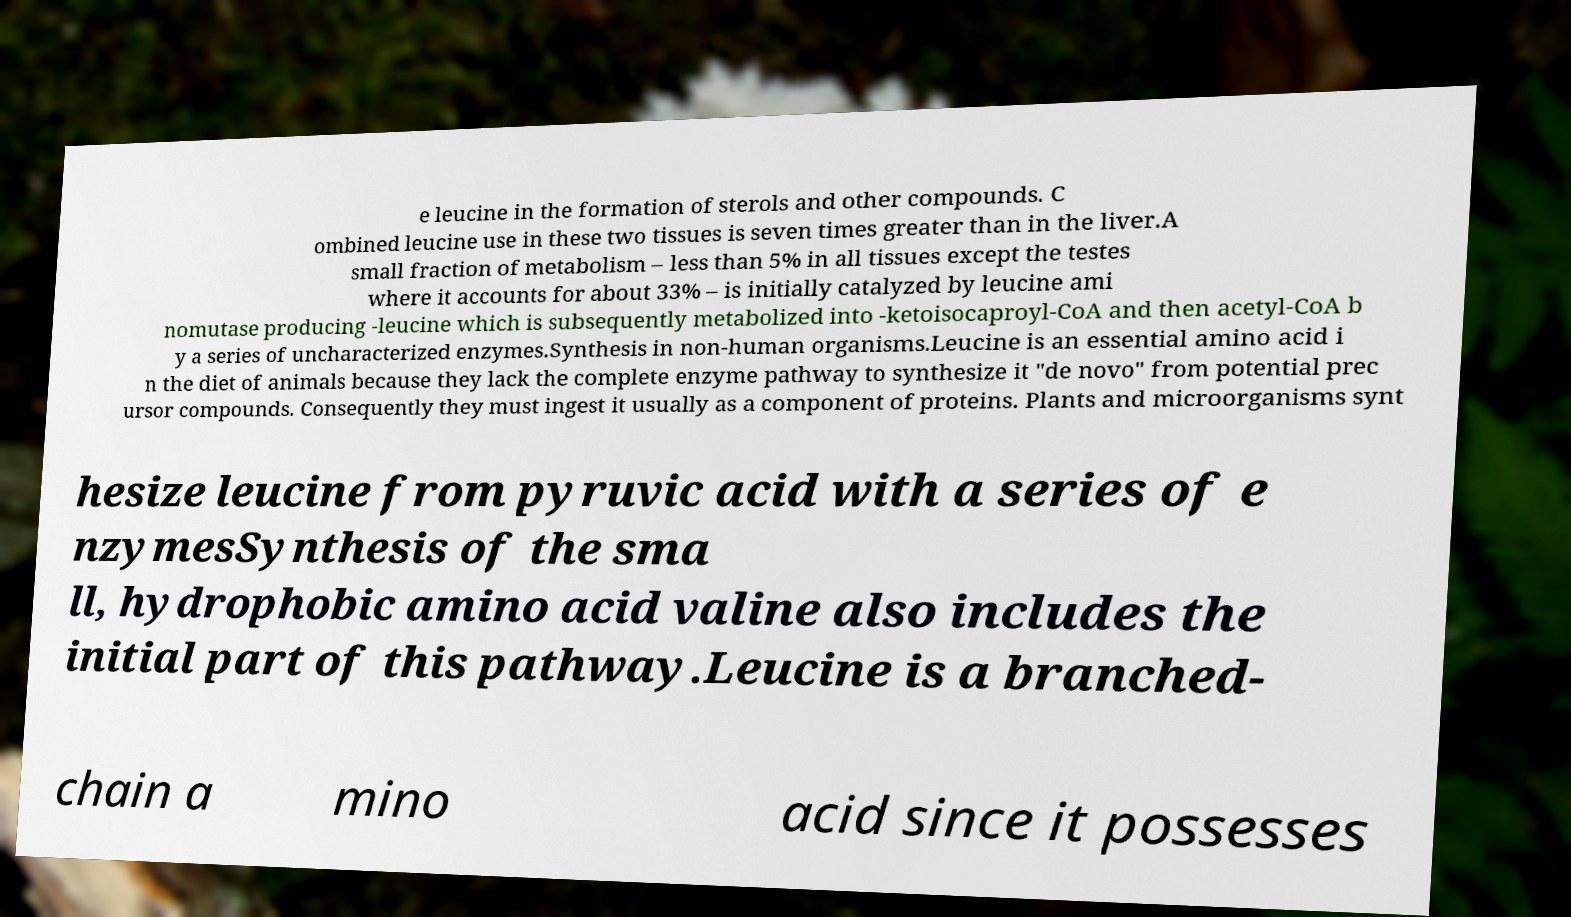Please identify and transcribe the text found in this image. e leucine in the formation of sterols and other compounds. C ombined leucine use in these two tissues is seven times greater than in the liver.A small fraction of metabolism – less than 5% in all tissues except the testes where it accounts for about 33% – is initially catalyzed by leucine ami nomutase producing -leucine which is subsequently metabolized into -ketoisocaproyl-CoA and then acetyl-CoA b y a series of uncharacterized enzymes.Synthesis in non-human organisms.Leucine is an essential amino acid i n the diet of animals because they lack the complete enzyme pathway to synthesize it "de novo" from potential prec ursor compounds. Consequently they must ingest it usually as a component of proteins. Plants and microorganisms synt hesize leucine from pyruvic acid with a series of e nzymesSynthesis of the sma ll, hydrophobic amino acid valine also includes the initial part of this pathway.Leucine is a branched- chain a mino acid since it possesses 